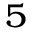Convert formula to latex. <formula><loc_0><loc_0><loc_500><loc_500>_ { 5 }</formula> 